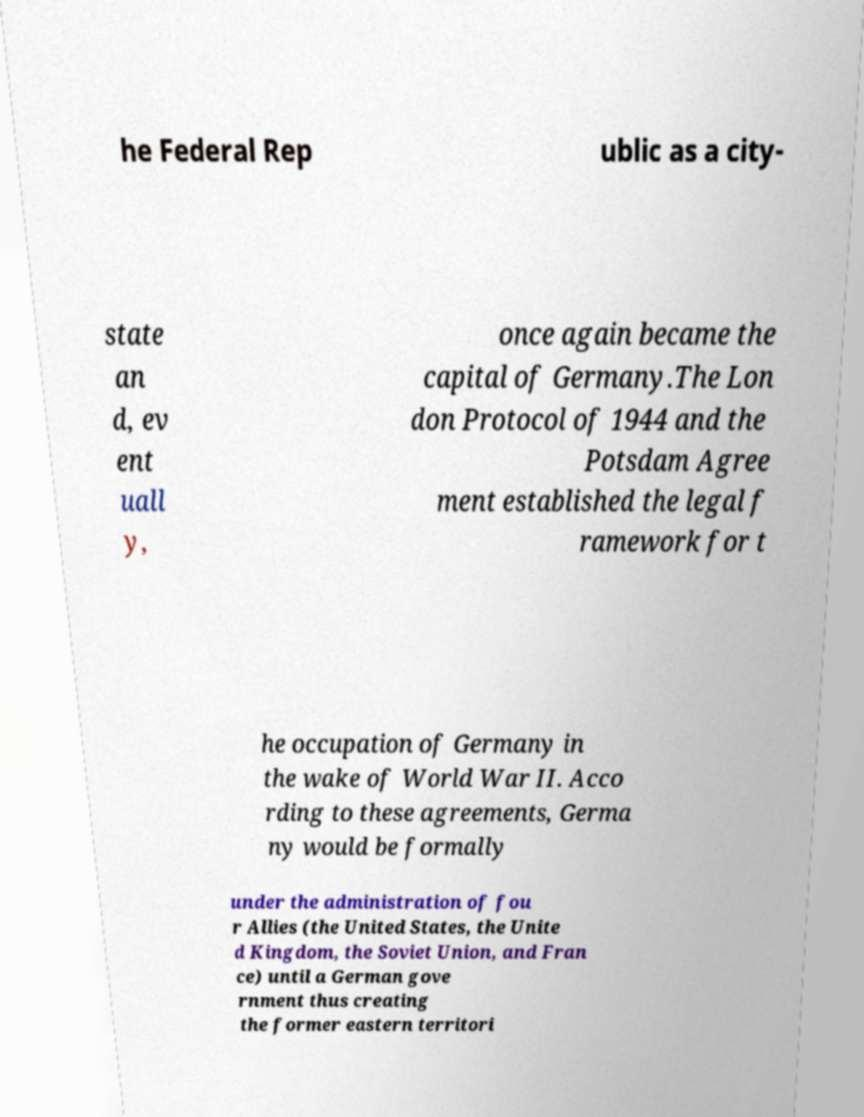Could you assist in decoding the text presented in this image and type it out clearly? he Federal Rep ublic as a city- state an d, ev ent uall y, once again became the capital of Germany.The Lon don Protocol of 1944 and the Potsdam Agree ment established the legal f ramework for t he occupation of Germany in the wake of World War II. Acco rding to these agreements, Germa ny would be formally under the administration of fou r Allies (the United States, the Unite d Kingdom, the Soviet Union, and Fran ce) until a German gove rnment thus creating the former eastern territori 